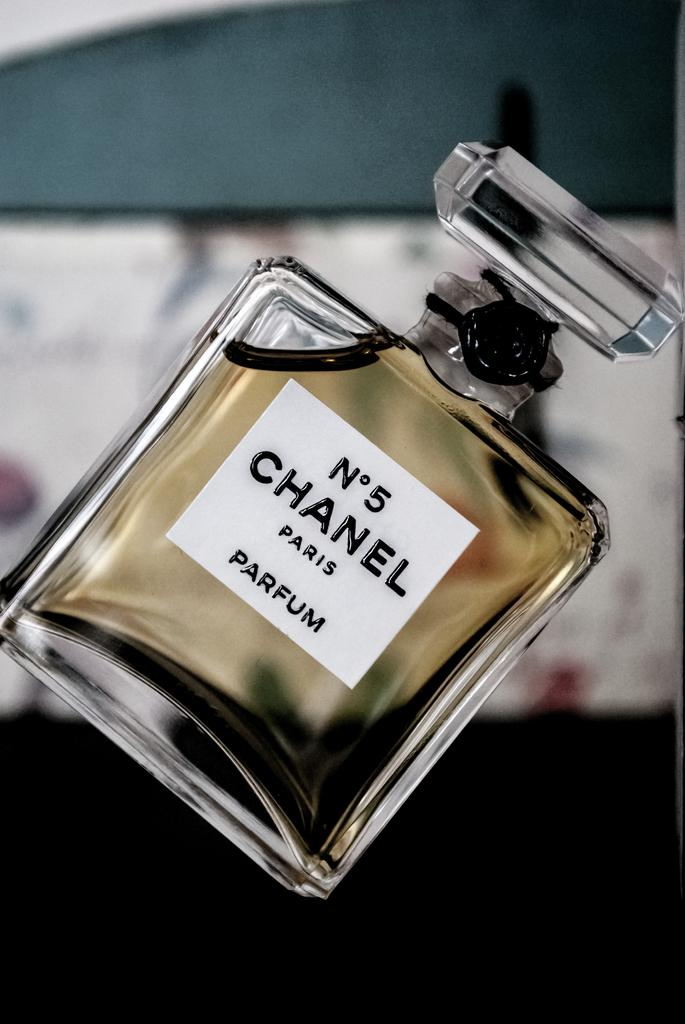<image>
Create a compact narrative representing the image presented. A bottle of Chanel No 5 on display. 